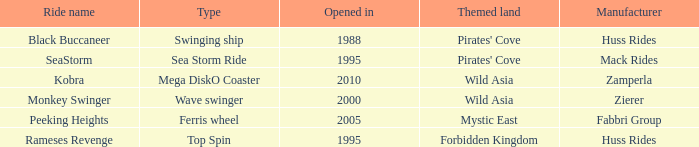Which ride opened after the 2000 Peeking Heights? Ferris wheel. Can you give me this table as a dict? {'header': ['Ride name', 'Type', 'Opened in', 'Themed land', 'Manufacturer'], 'rows': [['Black Buccaneer', 'Swinging ship', '1988', "Pirates' Cove", 'Huss Rides'], ['SeaStorm', 'Sea Storm Ride', '1995', "Pirates' Cove", 'Mack Rides'], ['Kobra', 'Mega DiskO Coaster', '2010', 'Wild Asia', 'Zamperla'], ['Monkey Swinger', 'Wave swinger', '2000', 'Wild Asia', 'Zierer'], ['Peeking Heights', 'Ferris wheel', '2005', 'Mystic East', 'Fabbri Group'], ['Rameses Revenge', 'Top Spin', '1995', 'Forbidden Kingdom', 'Huss Rides']]} 